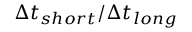<formula> <loc_0><loc_0><loc_500><loc_500>\Delta t _ { s h o r t } / \Delta t _ { l o n g }</formula> 